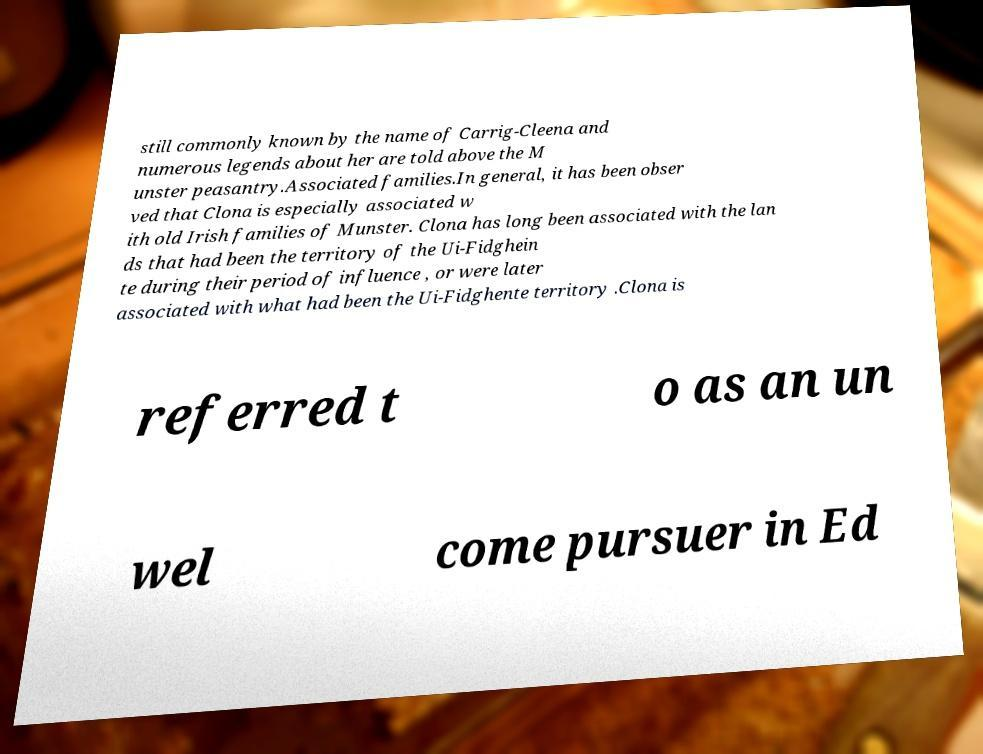Can you read and provide the text displayed in the image?This photo seems to have some interesting text. Can you extract and type it out for me? still commonly known by the name of Carrig-Cleena and numerous legends about her are told above the M unster peasantry.Associated families.In general, it has been obser ved that Clona is especially associated w ith old Irish families of Munster. Clona has long been associated with the lan ds that had been the territory of the Ui-Fidghein te during their period of influence , or were later associated with what had been the Ui-Fidghente territory .Clona is referred t o as an un wel come pursuer in Ed 